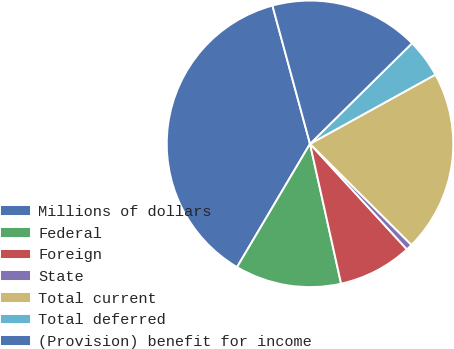Convert chart to OTSL. <chart><loc_0><loc_0><loc_500><loc_500><pie_chart><fcel>Millions of dollars<fcel>Federal<fcel>Foreign<fcel>State<fcel>Total current<fcel>Total deferred<fcel>(Provision) benefit for income<nl><fcel>37.27%<fcel>11.99%<fcel>8.34%<fcel>0.71%<fcel>20.5%<fcel>4.36%<fcel>16.84%<nl></chart> 